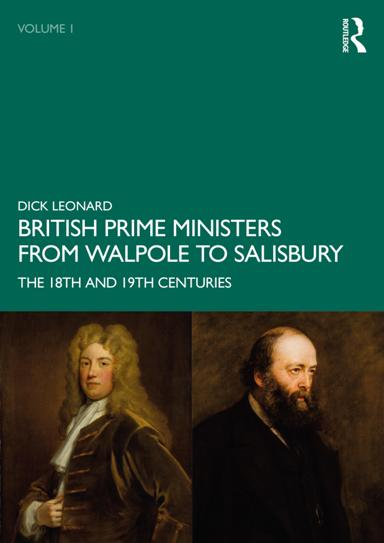Can you describe the two individuals depicted on the cover of the book? The cover of the book shows Sir Robert Walpole, who is often regarded as the first de facto Prime Minister of Great Britain, and Lord Salisbury, a prominent statesman of the late 19th century. Both were pivotal in shaping British politics during their respective tenures. 